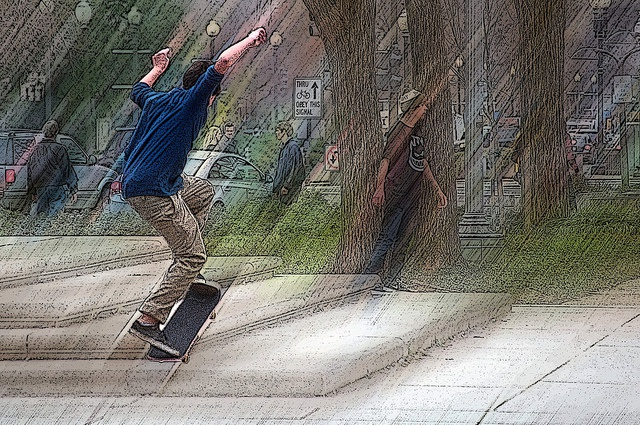Describe the objects in this image and their specific colors. I can see people in gray, black, navy, and darkgray tones, people in gray and black tones, car in gray and black tones, car in gray, darkgray, black, and lightgray tones, and people in gray, black, and blue tones in this image. 